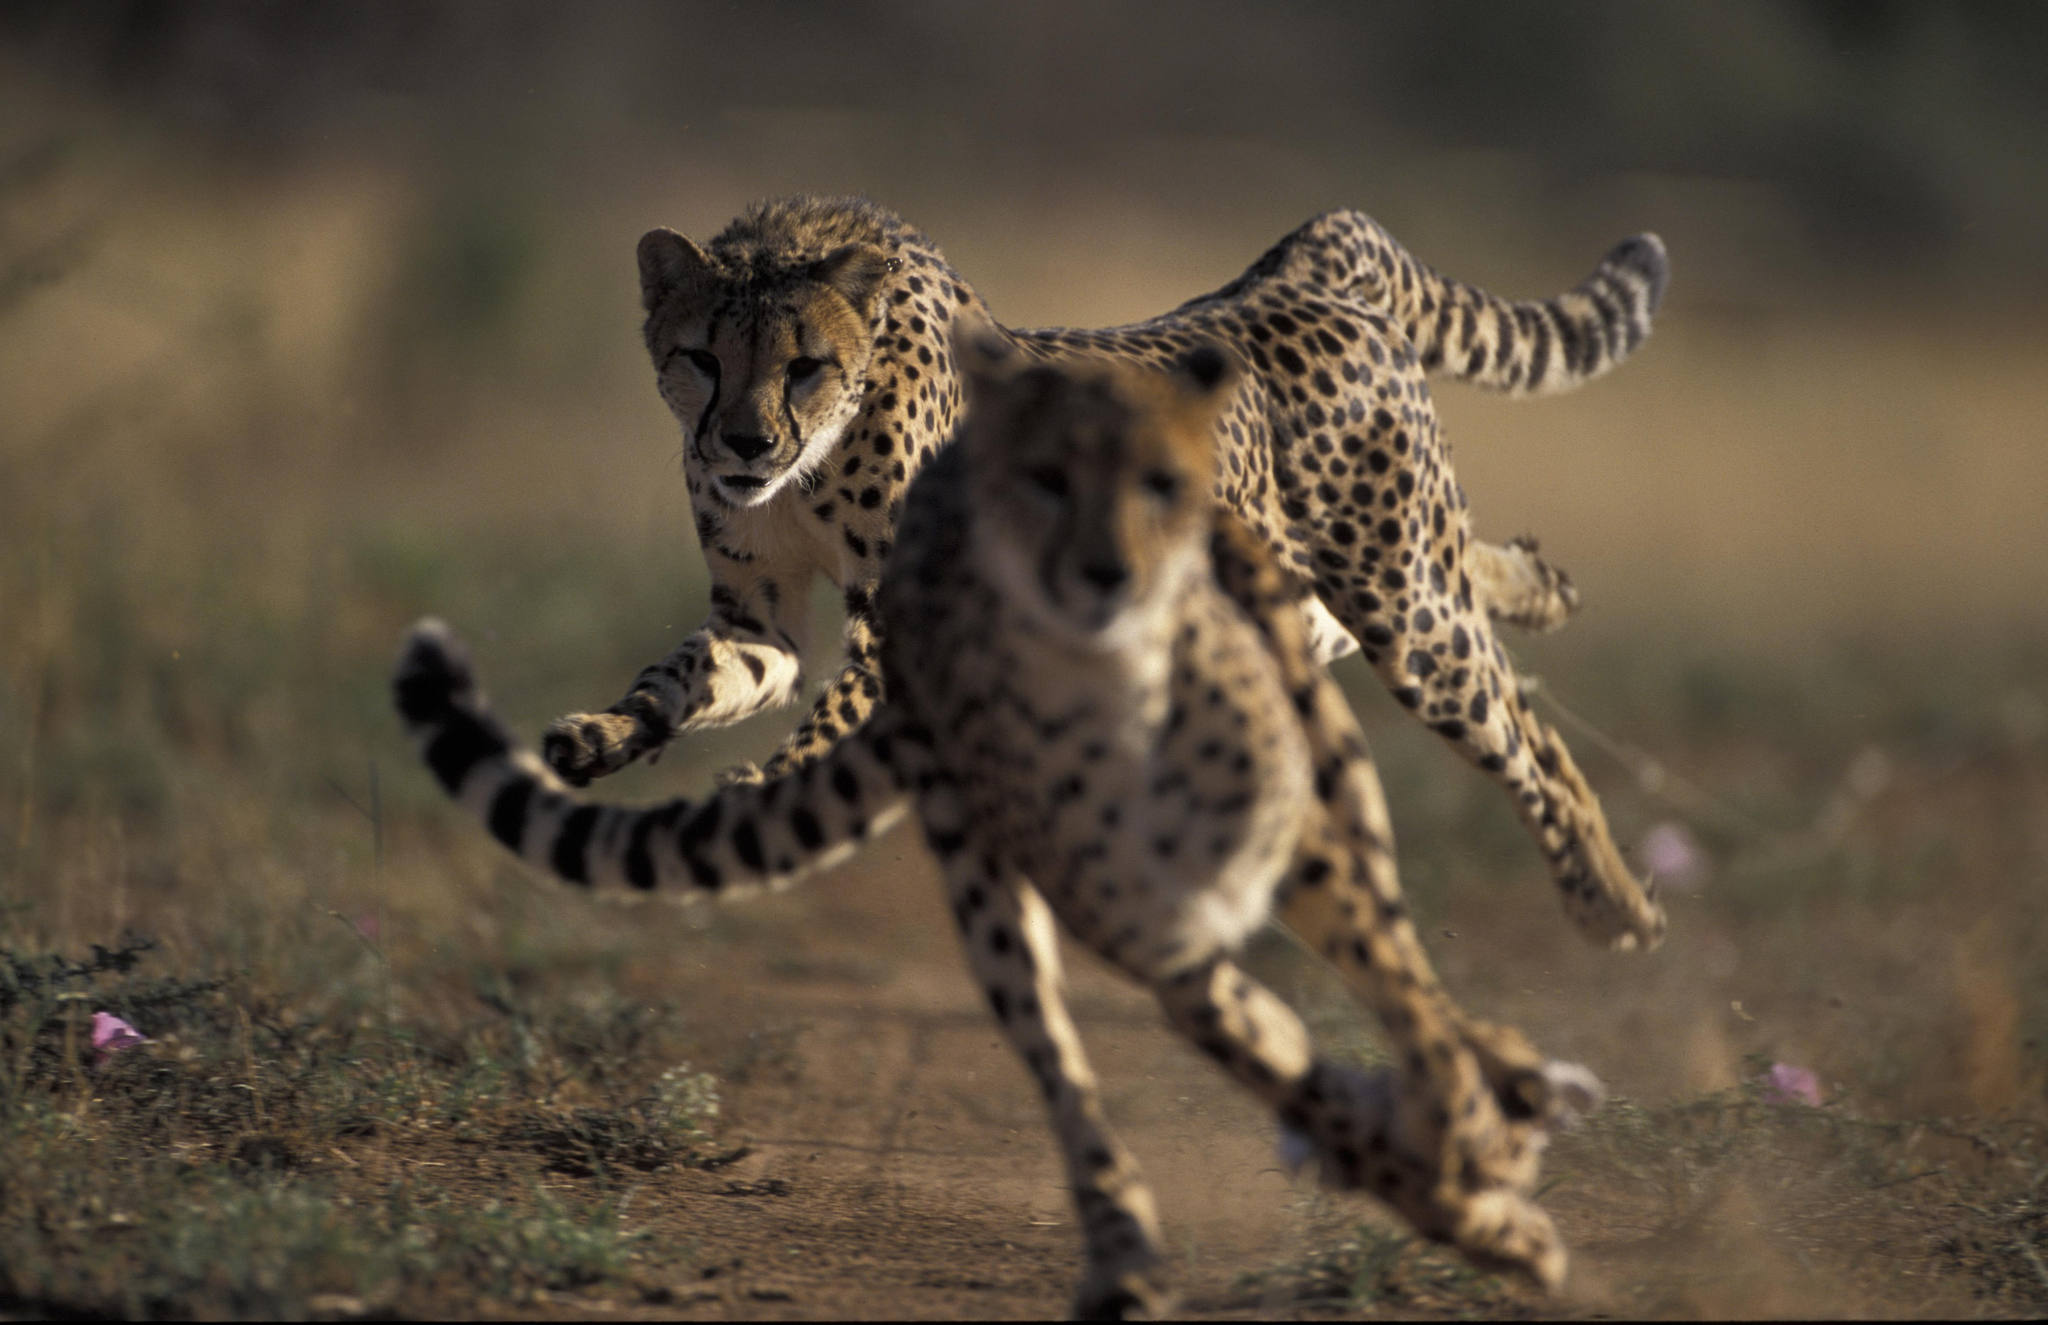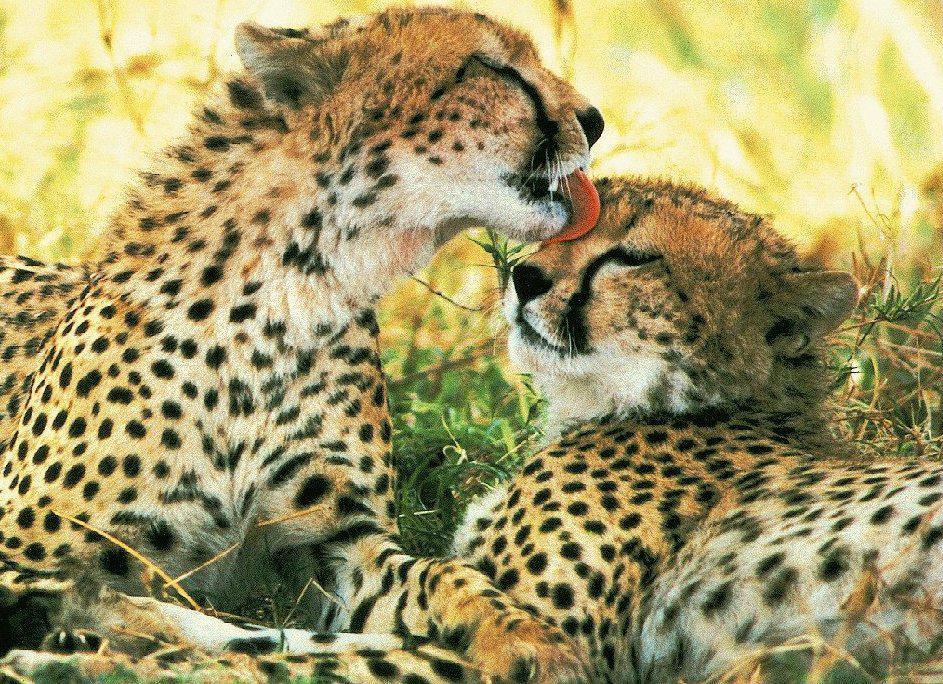The first image is the image on the left, the second image is the image on the right. For the images shown, is this caption "An image shows one wild cat with its mouth and paw on the other wild cat." true? Answer yes or no. Yes. The first image is the image on the left, the second image is the image on the right. Assess this claim about the two images: "There are a total of 6 or more wild cats.". Correct or not? Answer yes or no. No. 